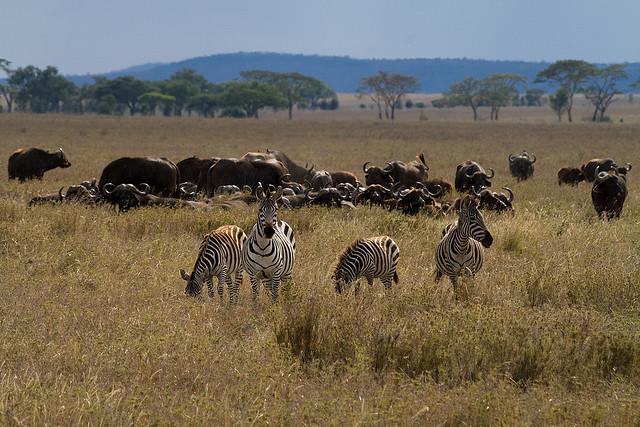Are these a herd of zebras?
Short answer required. No. How many zebras?
Short answer required. 4. What animals are these?
Write a very short answer. Zebras. Are the animals in captivity?
Answer briefly. No. What kind of animals are in the field?
Answer briefly. Zebras. How many different types of animals do you see?
Give a very brief answer. 2. What wild animal is this?
Give a very brief answer. Zebra. How many trees are there?
Be succinct. 10. Are these animals peaceful?
Keep it brief. Yes. 